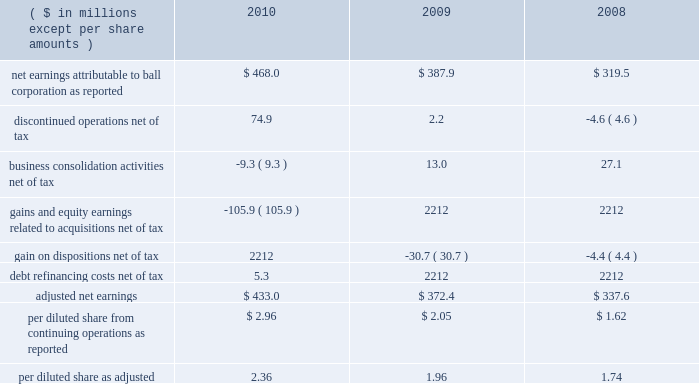Page 26 of 100 our calculation of adjusted net earnings is summarized below: .
Debt facilities and refinancing interest-bearing debt at december 31 , 2010 , increased $ 216.1 million to $ 2.8 billion from $ 2.6 billion at december 31 , 2009 .
In december 2010 , ball replaced its senior credit facilities due october 2011 with new senior credit facilities due december 2015 .
The senior credit facilities bear interest at variable rates and include a $ 200 million term a loan denominated in u.s .
Dollars , a a351 million term b loan denominated in british sterling and a 20ac100 million term c loan denominated in euros .
The facilities also include ( 1 ) a multi-currency , long-term revolving credit facility that provides the company with up to approximately $ 850 million and ( 2 ) a french multi-currency revolving facility that provides the company with up to $ 150 million .
The revolving credit facilities expire in december 2015 .
In november 2010 , ball issued $ 500 million of new 5.75 percent senior notes due in may 2021 .
The net proceeds from this offering were used to repay the borrowings under our term d loan facility and for general corporate purposes .
In march 2010 , ball issued $ 500 million of new 6.75 percent senior notes due in september 2020 .
On that same date , the company issued a notice of redemption to call $ 509 million in 6.875 percent senior notes due december 2012 at a redemption price of 101.146 percent of the outstanding principal amount plus accrued interest .
The redemption of the bonds occurred on april 21 , 2010 , and resulted in a charge of $ 8.1 million for the call premium and the write off of unamortized financing costs and unamortized premiums .
The charge is included in the 2010 statement of earnings as a component of interest expense .
At december 31 , 2010 , approximately $ 976 million was available under the company 2019s committed multi-currency revolving credit facilities .
The company 2019s prc operations also had approximately $ 20 million available under a committed credit facility of approximately $ 52 million .
In addition to the long-term committed credit facilities , the company had $ 372 million of short-term uncommitted credit facilities available at the end of 2010 , of which $ 76.2 million was outstanding and due on demand , as well as approximately $ 175 million of available borrowings under its accounts receivable securitization program .
In october 2010 , the company renewed its receivables sales agreement for a period of one year .
The size of the new program will vary between a maximum of $ 125 million for settlement dates in january through april and a maximum of $ 175 million for settlement dates in the remaining months .
Given our free cash flow projections and unused credit facilities that are available until december 2015 , our liquidity is strong and is expected to meet our ongoing operating cash flow and debt service requirements .
While the recent financial and economic conditions have raised concerns about credit risk with counterparties to derivative transactions , the company mitigates its exposure by spreading the risk among various counterparties and limiting exposure to any one party .
We also monitor the credit ratings of our suppliers , customers , lenders and counterparties on a regular basis .
We were in compliance with all loan agreements at december 31 , 2010 , and all prior years presented , and have met all debt payment obligations .
The u.s .
Note agreements , bank credit agreement and industrial development revenue bond agreements contain certain restrictions relating to dividends , investments , financial ratios , guarantees and the incurrence of additional indebtedness .
Additional details about our debt and receivables sales agreements are available in notes 12 and 6 , respectively , accompanying the consolidated financial statements within item 8 of this report. .
What was the percentage change in per diluted share earnings as adjusted from 2009 to 2010? 
Computations: ((2.36 - 1.96) / 1.96)
Answer: 0.20408. 